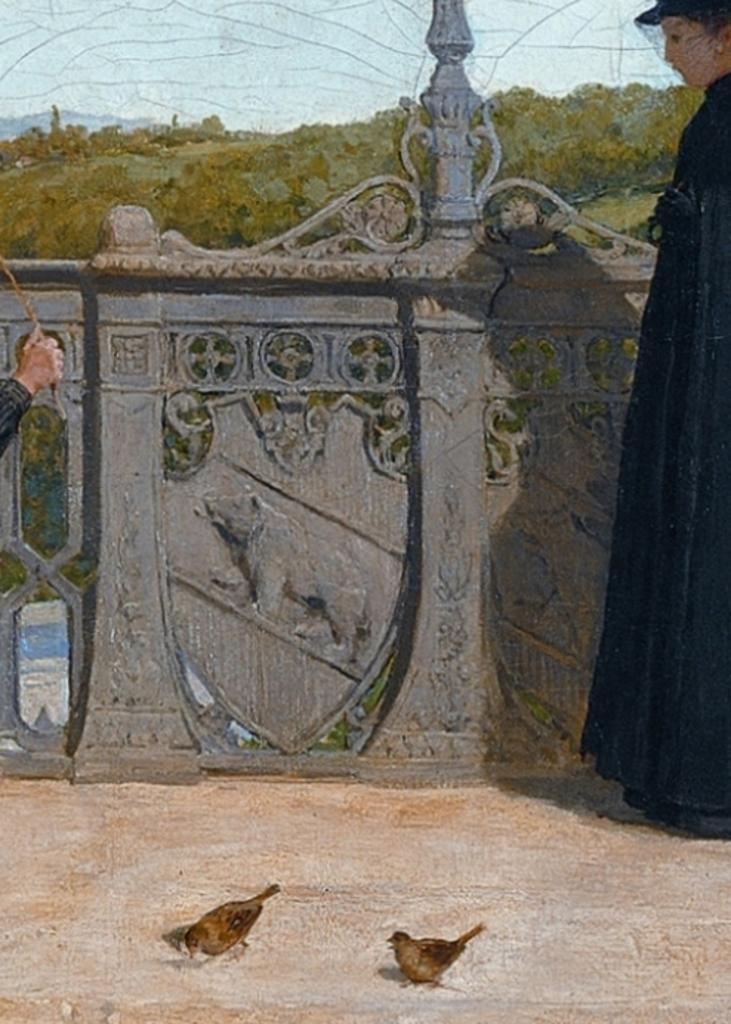In one or two sentences, can you explain what this image depicts? In this image I can see two persons standing, few birds, the railing, few trees and in the background I can see a mountain and the sky. 